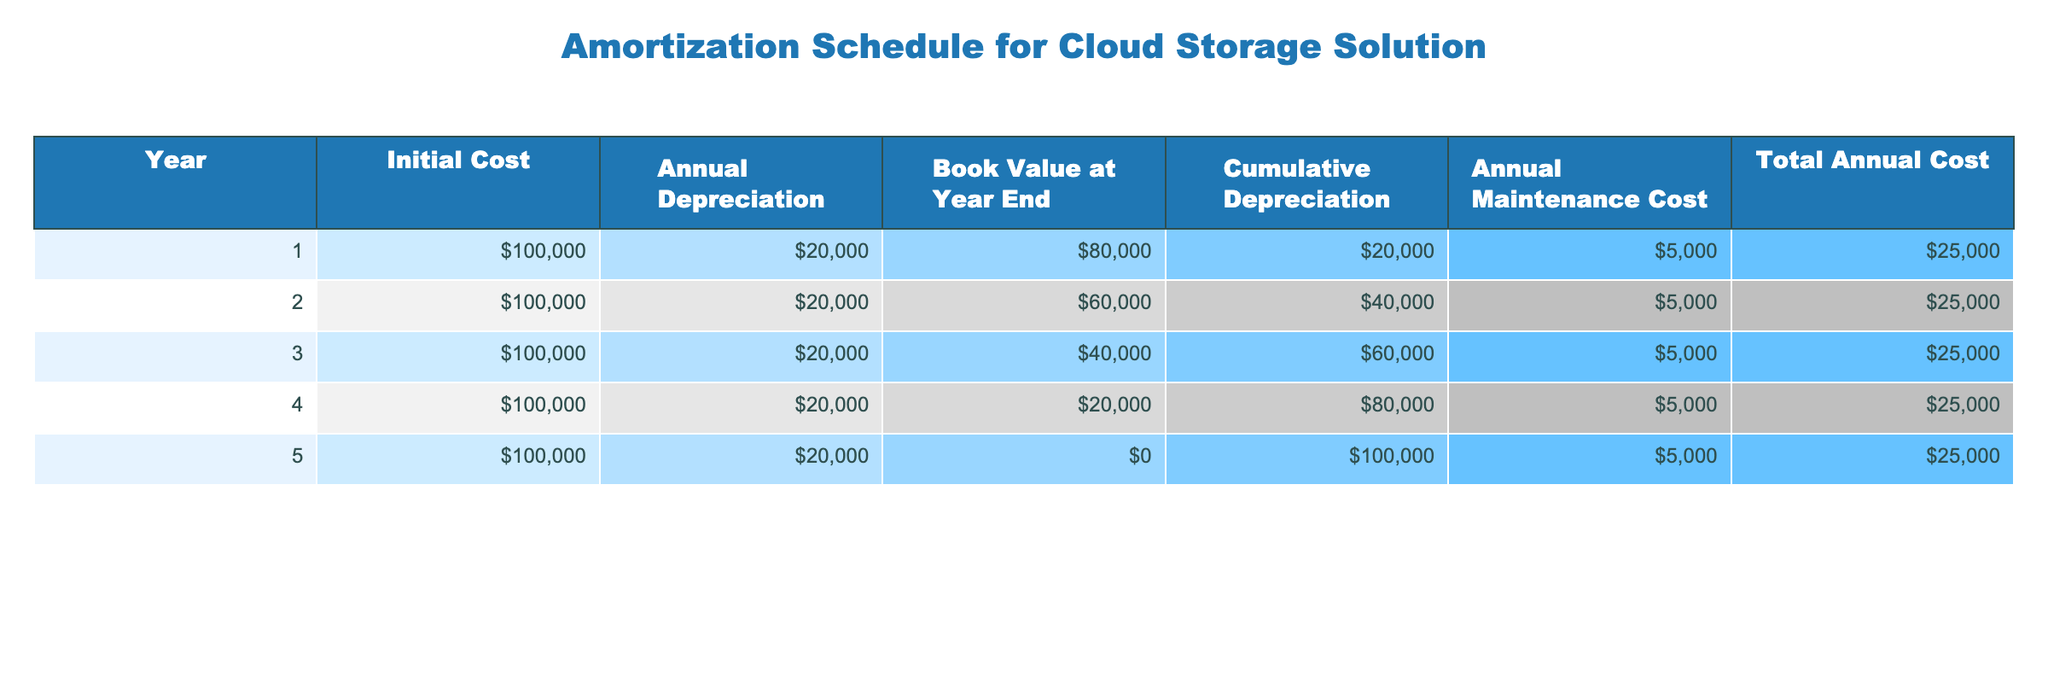What is the total annual cost in the fourth year? In the table, the total annual cost for the fourth year is found in the "Total Annual Cost" column under the row for Year 4. The value is 25000.
Answer: 25000 What is the cumulative depreciation by the end of Year 3? To find the cumulative depreciation by Year 3, we look at the "Cumulative Depreciation" column under the row for Year 3. The value is 60000.
Answer: 60000 Is the book value at year end equal to the initial cost minus the cumulative depreciation? To answer this, we check the "Book Value at Year End" for Year 5, which is 0, and the cumulative depreciation is 100000. Since 100000 (initial cost) minus 100000 (cumulative depreciation) equals 0, the statement is true.
Answer: Yes What is the average annual depreciation over the 5 years? To calculate the average annual depreciation, we sum the annual depreciation for all 5 years: (20000 + 20000 + 20000 + 20000 + 20000) = 100000. Then, we divide by 5, which gives 100000 / 5 = 20000.
Answer: 20000 In which year does the total annual cost remain the same? Reviewing the "Total Annual Cost" column, we see that the value is consistently 25000 for all five years. Therefore, it remains the same each year.
Answer: All years What is the change in book value from Year 1 to Year 2? The book value at Year 1 is 80000 and at Year 2 is 60000. The change is calculated as 60000 - 80000 = -20000, indicating a decrease of 20000.
Answer: -20000 Does the annual maintenance cost change over the years? In the "Annual Maintenance Cost" column, we see that the value is consistently 5000 for all five years. Therefore, it does not change.
Answer: No What is the difference in cumulative depreciation between Year 1 and Year 4? The cumulative depreciation for Year 1 is 20000 and for Year 4 it is 80000. The difference is calculated as 80000 - 20000 = 60000.
Answer: 60000 